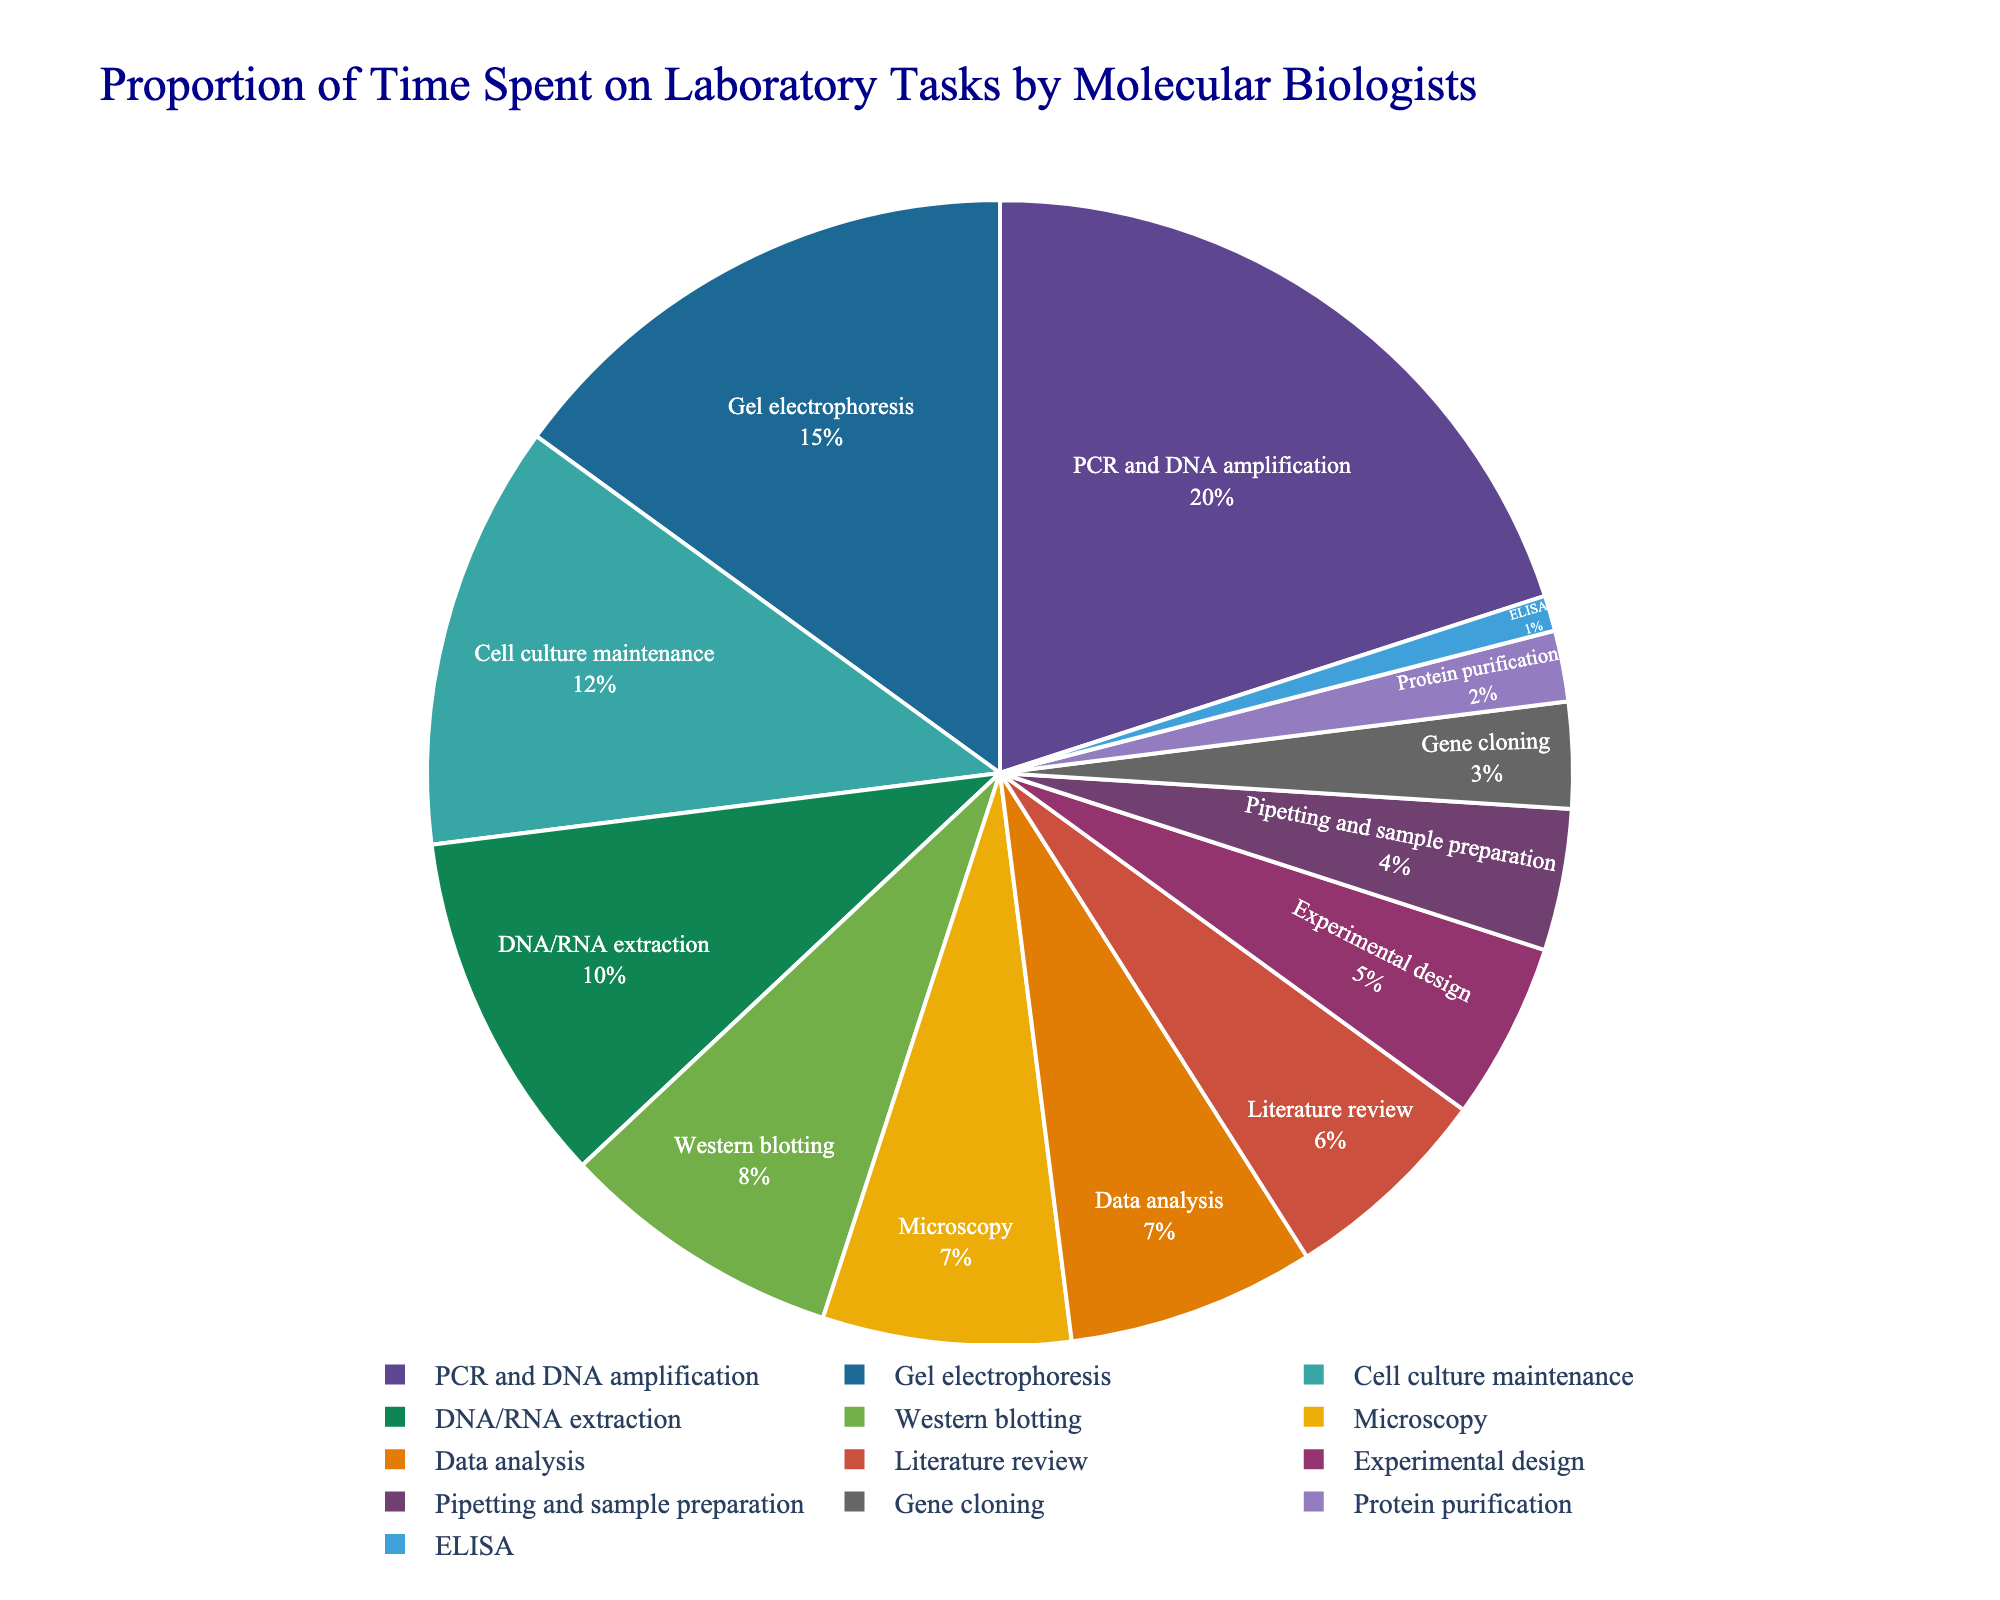What's the task with the highest proportion of time spent? The task with the largest slice of the pie chart is the one with the highest percentage. Looking at the chart, "PCR and DNA amplification" has the largest slice.
Answer: PCR and DNA amplification What's the combined percentage of time spent on Gel electrophoresis and Cell culture maintenance? Add the percentages of "Gel electrophoresis" (15%) and "Cell culture maintenance" (12%) together. 15 + 12 = 27.
Answer: 27% Which task has a lower proportion of time spent, Microscopy or DNA/RNA extraction? Compare the percentages of "Microscopy" (7%) and "DNA/RNA extraction" (10%). Since 7 < 10, "Microscopy" has a lower proportion.
Answer: Microscopy Are there more tasks with a time proportion above 10% or below 5%? Count the tasks with percentages above 10% (PCR and DNA amplification, Gel electrophoresis, and Cell culture maintenance), which is 3. Count the tasks with percentages below 5% (Pipetting and sample preparation, Gene cloning, Protein purification, and ELISA), which is 4. Since 4 > 3, there are more tasks below 5%.
Answer: Below 5% What's the visual position of the legend in the pie chart? The legend is positioned horizontally at the bottom center of the pie chart, below the chart itself.
Answer: Bottom center What's the total percentage of tasks related to direct experimental procedures (PCR and DNA amplification, Gel electrophoresis, Cell culture maintenance, DNA/RNA extraction, Western blotting, Microscopy)? Sum the percentages of all listed tasks: 20 + 15 + 12 + 10 + 8 + 7 = 72.
Answer: 72% Which task is represented by the color with the smallest proportion in the pie chart? The smallest slice of the pie chart represents the task with the smallest proportion, which is "ELISA" with 1%. Look at the color of this smallest slice.
Answer: ELISA 